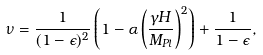<formula> <loc_0><loc_0><loc_500><loc_500>\nu = \frac { 1 } { ( 1 - \epsilon ) ^ { 2 } } \left ( 1 - \alpha \left ( \frac { \gamma { H } } { M _ { P l } } \right ) ^ { 2 } \right ) + \frac { 1 } { 1 - \epsilon } ,</formula> 